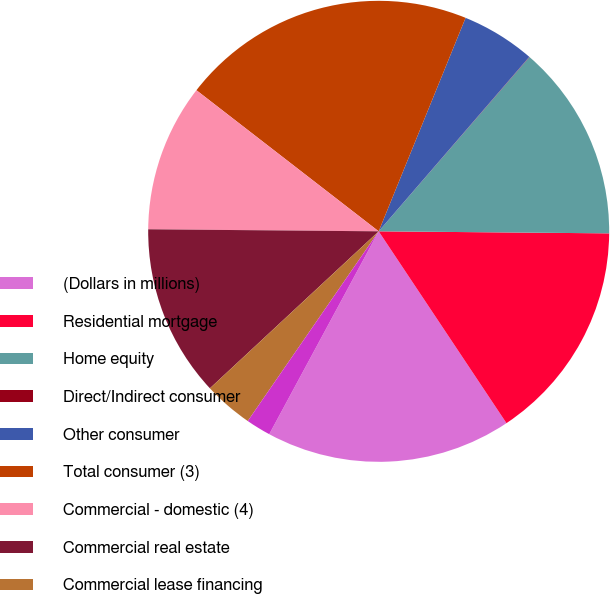Convert chart. <chart><loc_0><loc_0><loc_500><loc_500><pie_chart><fcel>(Dollars in millions)<fcel>Residential mortgage<fcel>Home equity<fcel>Direct/Indirect consumer<fcel>Other consumer<fcel>Total consumer (3)<fcel>Commercial - domestic (4)<fcel>Commercial real estate<fcel>Commercial lease financing<fcel>Commercial - foreign<nl><fcel>17.22%<fcel>15.5%<fcel>13.78%<fcel>0.02%<fcel>5.18%<fcel>20.66%<fcel>10.34%<fcel>12.06%<fcel>3.46%<fcel>1.74%<nl></chart> 